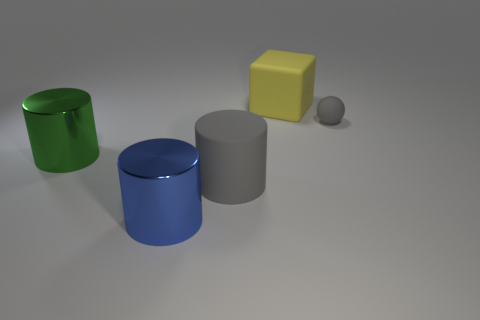Are there any other things that are the same size as the yellow block?
Make the answer very short. Yes. There is a large object that is to the right of the big gray object; is its color the same as the big matte cylinder?
Make the answer very short. No. How many gray rubber objects are the same shape as the green thing?
Your response must be concise. 1. Are there an equal number of objects right of the small matte ball and big gray matte cylinders?
Provide a short and direct response. No. There is a rubber cylinder that is the same size as the yellow cube; what color is it?
Provide a short and direct response. Gray. Are there any other tiny gray objects of the same shape as the tiny gray matte object?
Offer a terse response. No. What material is the object that is left of the cylinder that is in front of the gray object left of the large yellow matte cube?
Keep it short and to the point. Metal. What number of other objects are the same size as the gray cylinder?
Offer a terse response. 3. What color is the tiny object?
Your answer should be compact. Gray. What number of shiny things are either green objects or purple objects?
Offer a terse response. 1. 